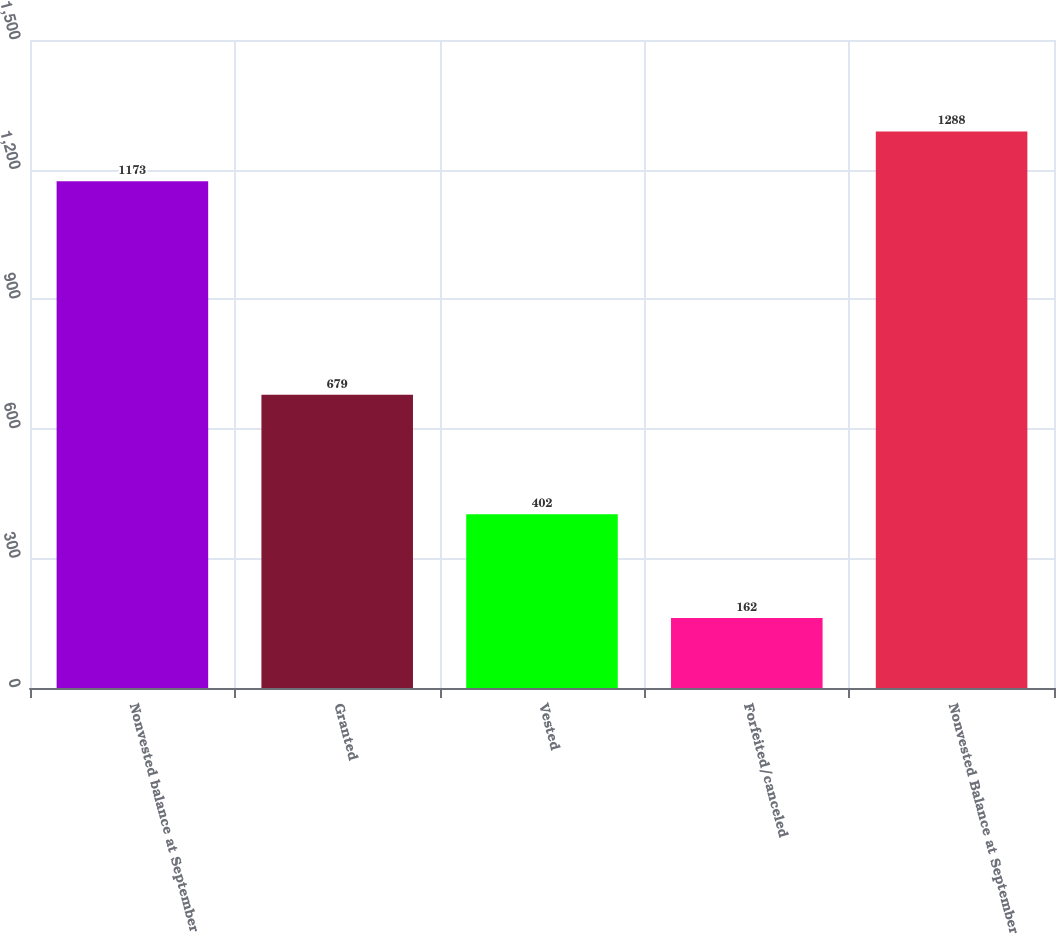Convert chart to OTSL. <chart><loc_0><loc_0><loc_500><loc_500><bar_chart><fcel>Nonvested balance at September<fcel>Granted<fcel>Vested<fcel>Forfeited/canceled<fcel>Nonvested Balance at September<nl><fcel>1173<fcel>679<fcel>402<fcel>162<fcel>1288<nl></chart> 